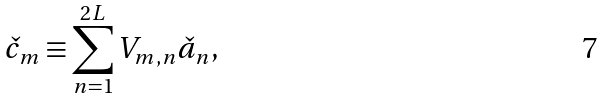<formula> <loc_0><loc_0><loc_500><loc_500>\check { c } _ { m } \equiv \sum _ { n = 1 } ^ { 2 L } V _ { m , n } \check { a } _ { n } ,</formula> 